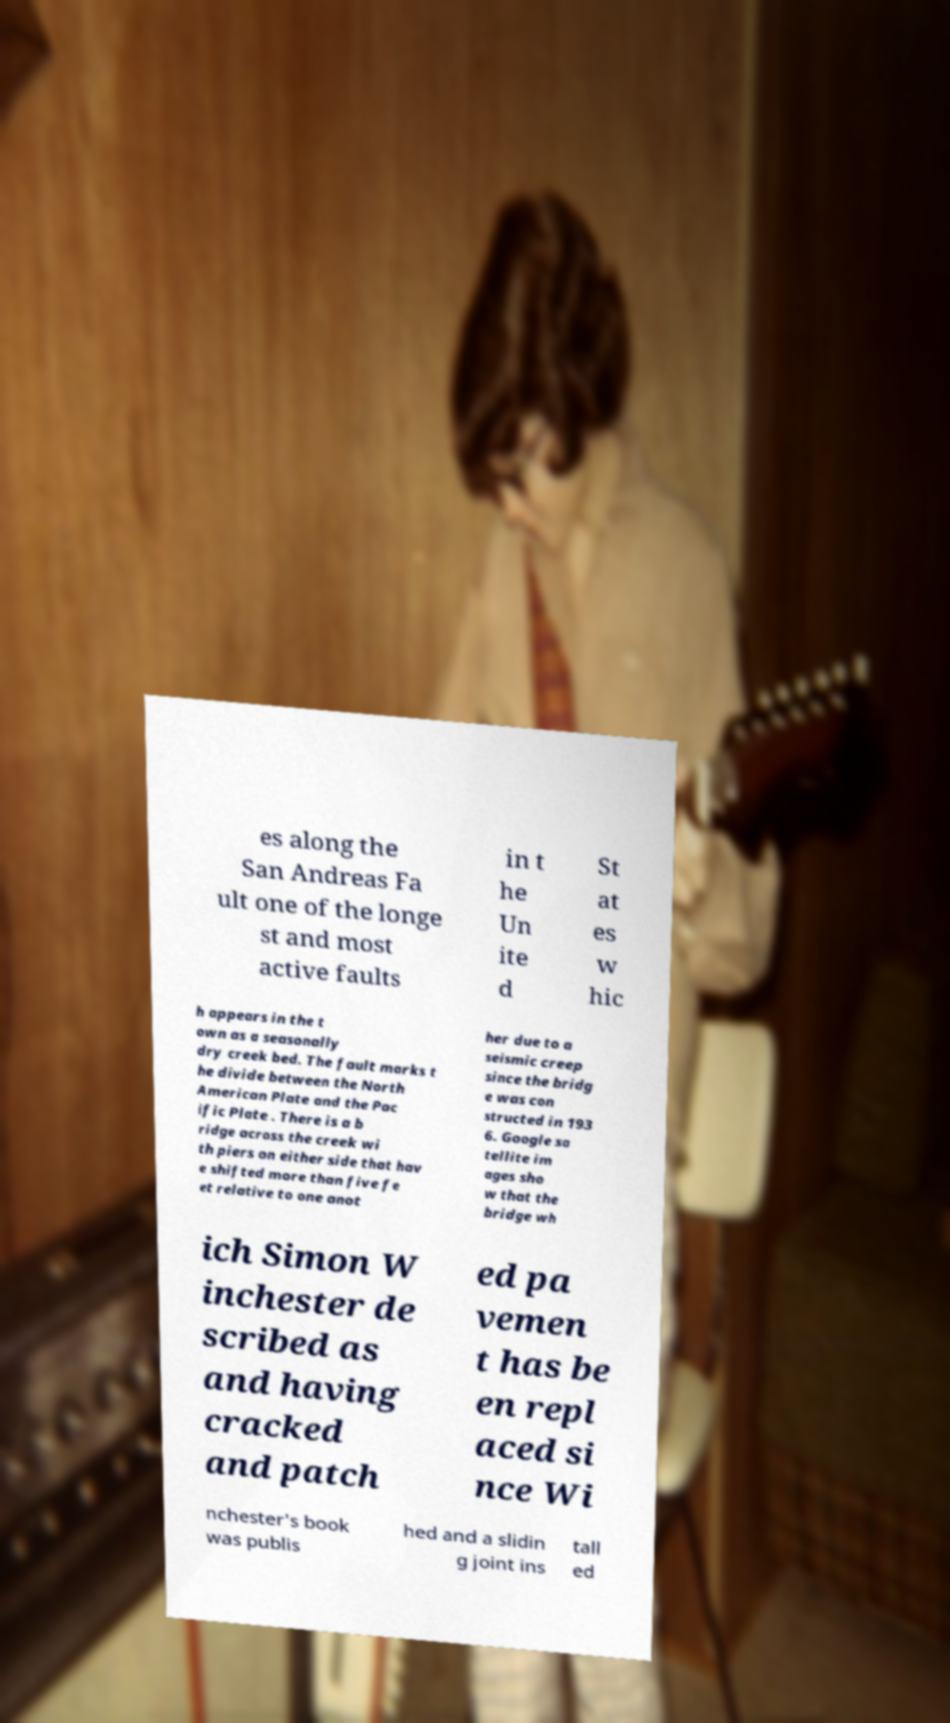For documentation purposes, I need the text within this image transcribed. Could you provide that? es along the San Andreas Fa ult one of the longe st and most active faults in t he Un ite d St at es w hic h appears in the t own as a seasonally dry creek bed. The fault marks t he divide between the North American Plate and the Pac ific Plate . There is a b ridge across the creek wi th piers on either side that hav e shifted more than five fe et relative to one anot her due to a seismic creep since the bridg e was con structed in 193 6. Google sa tellite im ages sho w that the bridge wh ich Simon W inchester de scribed as and having cracked and patch ed pa vemen t has be en repl aced si nce Wi nchester's book was publis hed and a slidin g joint ins tall ed 